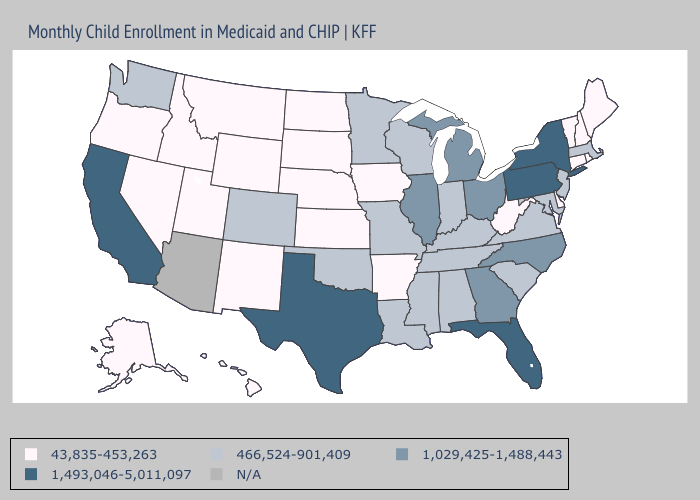Name the states that have a value in the range 1,493,046-5,011,097?
Write a very short answer. California, Florida, New York, Pennsylvania, Texas. Name the states that have a value in the range 1,493,046-5,011,097?
Quick response, please. California, Florida, New York, Pennsylvania, Texas. What is the highest value in the USA?
Quick response, please. 1,493,046-5,011,097. What is the value of Missouri?
Concise answer only. 466,524-901,409. Among the states that border Massachusetts , which have the lowest value?
Keep it brief. Connecticut, New Hampshire, Rhode Island, Vermont. What is the value of North Dakota?
Be succinct. 43,835-453,263. Name the states that have a value in the range 43,835-453,263?
Concise answer only. Alaska, Arkansas, Connecticut, Delaware, Hawaii, Idaho, Iowa, Kansas, Maine, Montana, Nebraska, Nevada, New Hampshire, New Mexico, North Dakota, Oregon, Rhode Island, South Dakota, Utah, Vermont, West Virginia, Wyoming. Among the states that border Texas , does Arkansas have the lowest value?
Be succinct. Yes. Which states have the lowest value in the USA?
Short answer required. Alaska, Arkansas, Connecticut, Delaware, Hawaii, Idaho, Iowa, Kansas, Maine, Montana, Nebraska, Nevada, New Hampshire, New Mexico, North Dakota, Oregon, Rhode Island, South Dakota, Utah, Vermont, West Virginia, Wyoming. What is the highest value in states that border Virginia?
Give a very brief answer. 1,029,425-1,488,443. What is the highest value in states that border Illinois?
Give a very brief answer. 466,524-901,409. What is the highest value in states that border New Hampshire?
Answer briefly. 466,524-901,409. 